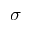<formula> <loc_0><loc_0><loc_500><loc_500>\sigma</formula> 